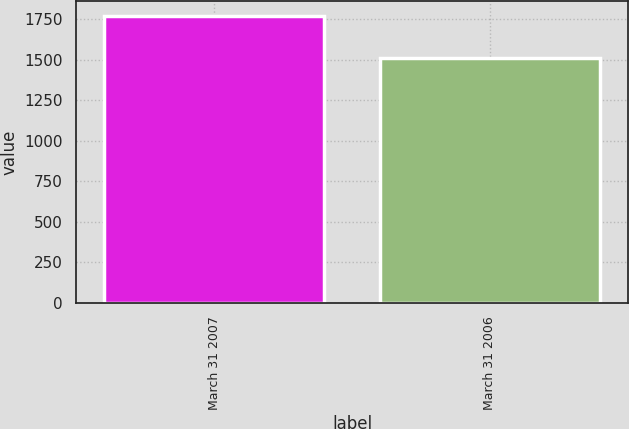Convert chart. <chart><loc_0><loc_0><loc_500><loc_500><bar_chart><fcel>March 31 2007<fcel>March 31 2006<nl><fcel>1772<fcel>1510<nl></chart> 